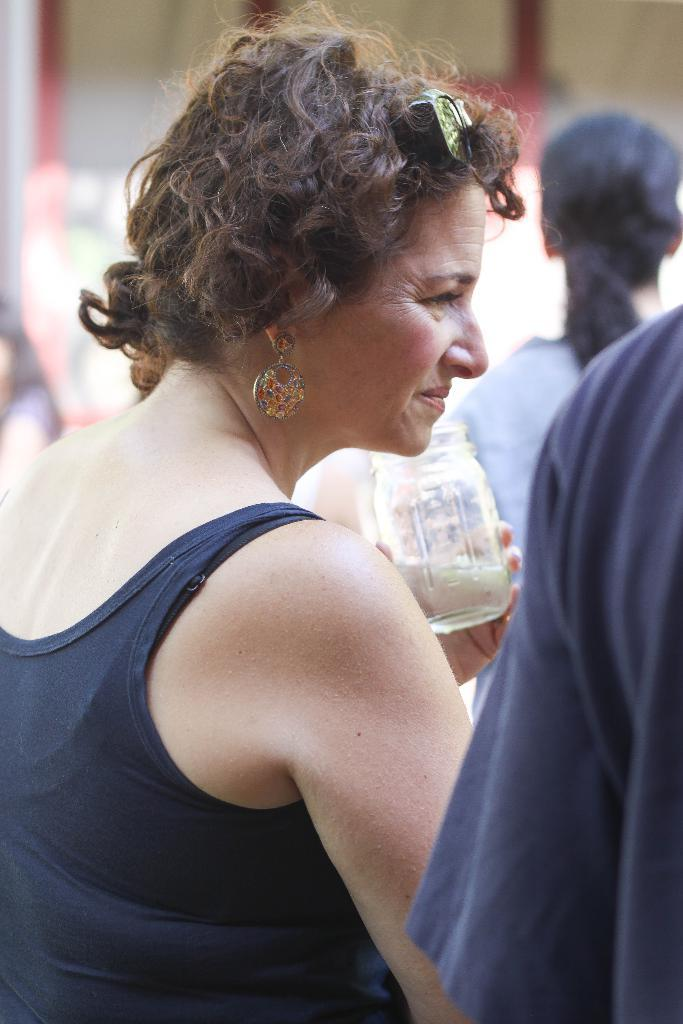What is the main subject of the image? The main subject of the image is a group of people. Are there any objects visible in the image? Yes, there is a glass jar in the image. Can you describe the background of the image? The background of the image contains other items, but their specifics are not mentioned in the provided facts. What type of disease is being treated with the wrench in the image? There is no wrench or disease present in the image. Who is wearing the crown in the image? There is no crown or person wearing a crown in the image. 